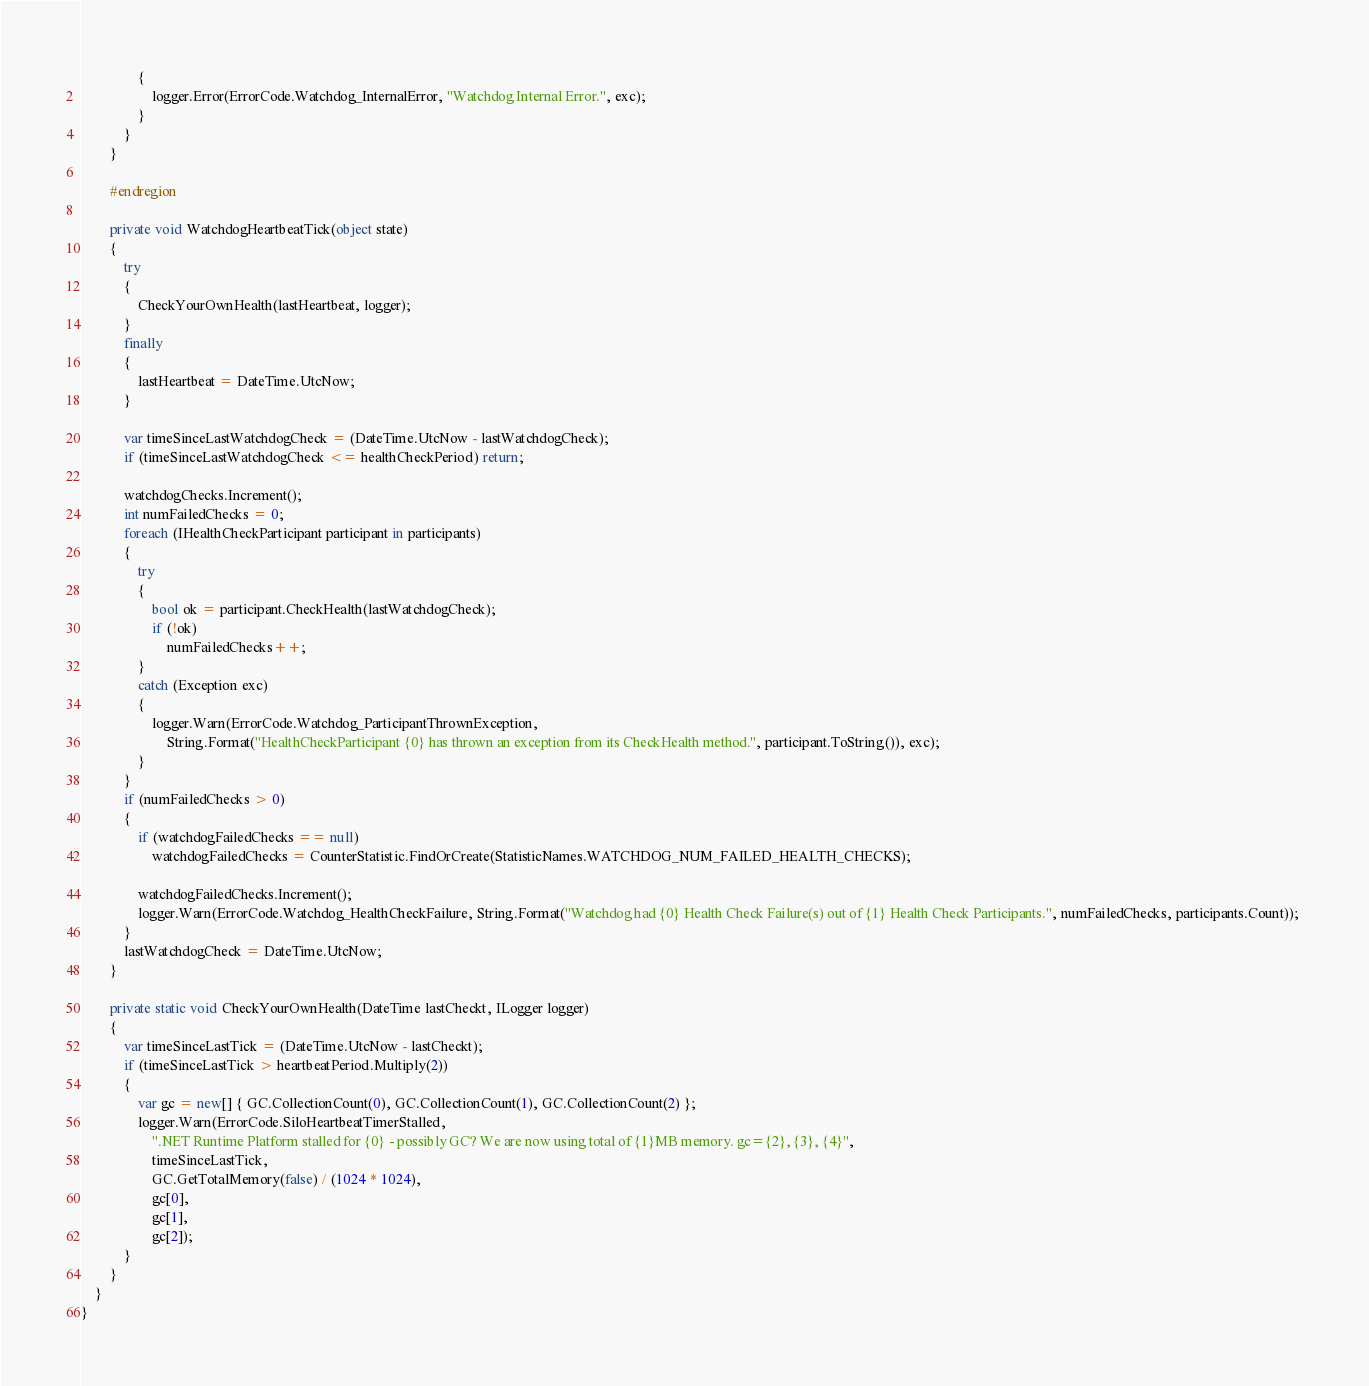<code> <loc_0><loc_0><loc_500><loc_500><_C#_>                {
                    logger.Error(ErrorCode.Watchdog_InternalError, "Watchdog Internal Error.", exc);
                }
            }
        }

        #endregion

        private void WatchdogHeartbeatTick(object state)
        {
            try
            {
                CheckYourOwnHealth(lastHeartbeat, logger);
            }
            finally
            {
                lastHeartbeat = DateTime.UtcNow;
            }
            
            var timeSinceLastWatchdogCheck = (DateTime.UtcNow - lastWatchdogCheck);
            if (timeSinceLastWatchdogCheck <= healthCheckPeriod) return;

            watchdogChecks.Increment();
            int numFailedChecks = 0;
            foreach (IHealthCheckParticipant participant in participants)
            {
                try
                {
                    bool ok = participant.CheckHealth(lastWatchdogCheck);
                    if (!ok)
                        numFailedChecks++;
                }
                catch (Exception exc) 
                {
                    logger.Warn(ErrorCode.Watchdog_ParticipantThrownException, 
                        String.Format("HealthCheckParticipant {0} has thrown an exception from its CheckHealth method.", participant.ToString()), exc); 
                }
            }
            if (numFailedChecks > 0)
            {
                if (watchdogFailedChecks == null)
                    watchdogFailedChecks = CounterStatistic.FindOrCreate(StatisticNames.WATCHDOG_NUM_FAILED_HEALTH_CHECKS);
                
                watchdogFailedChecks.Increment();
                logger.Warn(ErrorCode.Watchdog_HealthCheckFailure, String.Format("Watchdog had {0} Health Check Failure(s) out of {1} Health Check Participants.", numFailedChecks, participants.Count)); 
            }
            lastWatchdogCheck = DateTime.UtcNow;
        }

        private static void CheckYourOwnHealth(DateTime lastCheckt, ILogger logger)
        {
            var timeSinceLastTick = (DateTime.UtcNow - lastCheckt);
            if (timeSinceLastTick > heartbeatPeriod.Multiply(2))
            {
                var gc = new[] { GC.CollectionCount(0), GC.CollectionCount(1), GC.CollectionCount(2) };
                logger.Warn(ErrorCode.SiloHeartbeatTimerStalled,
                    ".NET Runtime Platform stalled for {0} - possibly GC? We are now using total of {1}MB memory. gc={2}, {3}, {4}",
                    timeSinceLastTick,
                    GC.GetTotalMemory(false) / (1024 * 1024),
                    gc[0],
                    gc[1],
                    gc[2]);
            }
        }
    }
}

</code> 